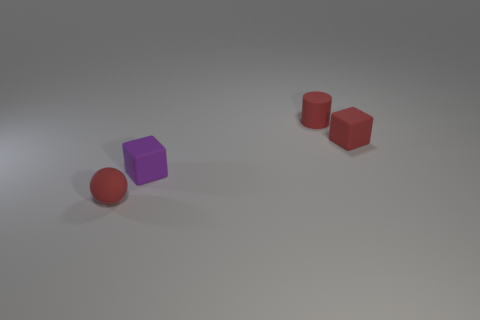Add 4 cubes. How many objects exist? 8 Subtract all big gray metallic cubes. Subtract all small purple rubber objects. How many objects are left? 3 Add 2 tiny purple blocks. How many tiny purple blocks are left? 3 Add 3 small brown metal blocks. How many small brown metal blocks exist? 3 Subtract 0 green balls. How many objects are left? 4 